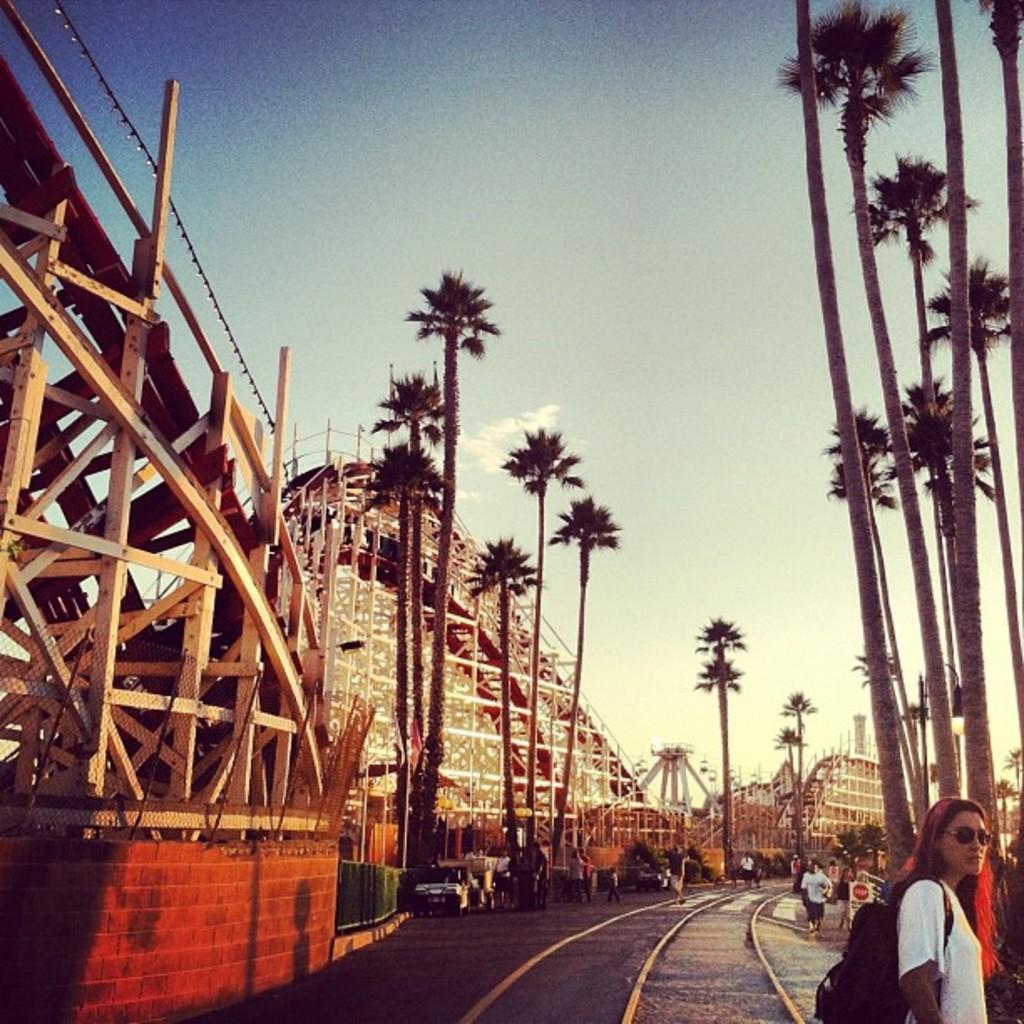How would you summarize this image in a sentence or two? In this image I can see towers ,trees and the sky , on the road I can see railway track and vehicles and persons walking on the road. 